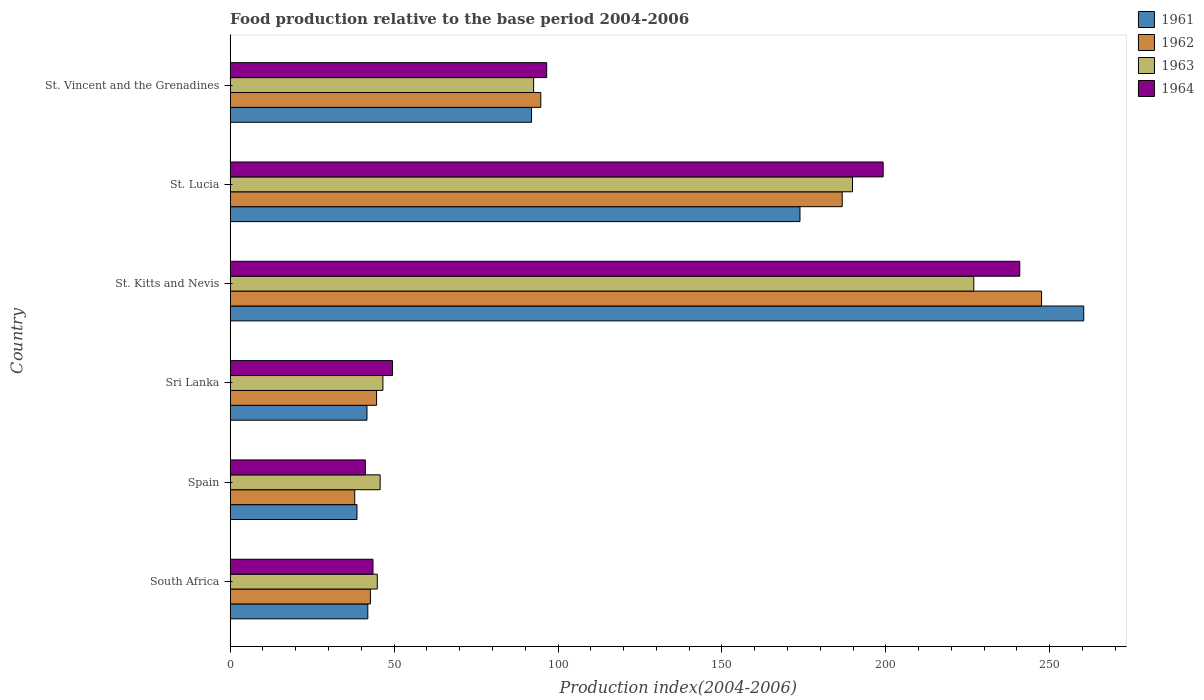How many groups of bars are there?
Keep it short and to the point. 6. Are the number of bars on each tick of the Y-axis equal?
Keep it short and to the point. Yes. How many bars are there on the 3rd tick from the top?
Your response must be concise. 4. How many bars are there on the 3rd tick from the bottom?
Provide a succinct answer. 4. What is the label of the 1st group of bars from the top?
Your answer should be compact. St. Vincent and the Grenadines. In how many cases, is the number of bars for a given country not equal to the number of legend labels?
Make the answer very short. 0. What is the food production index in 1961 in South Africa?
Make the answer very short. 41.98. Across all countries, what is the maximum food production index in 1962?
Ensure brevity in your answer.  247.5. Across all countries, what is the minimum food production index in 1962?
Make the answer very short. 37.99. In which country was the food production index in 1964 maximum?
Your answer should be very brief. St. Kitts and Nevis. In which country was the food production index in 1961 minimum?
Your answer should be very brief. Spain. What is the total food production index in 1963 in the graph?
Provide a short and direct response. 646.42. What is the difference between the food production index in 1963 in St. Kitts and Nevis and that in St. Vincent and the Grenadines?
Ensure brevity in your answer.  134.27. What is the difference between the food production index in 1964 in St. Vincent and the Grenadines and the food production index in 1961 in Sri Lanka?
Offer a terse response. 54.82. What is the average food production index in 1961 per country?
Ensure brevity in your answer.  108.08. What is the difference between the food production index in 1961 and food production index in 1963 in St. Lucia?
Provide a short and direct response. -16.02. In how many countries, is the food production index in 1962 greater than 100 ?
Provide a succinct answer. 2. What is the ratio of the food production index in 1962 in Spain to that in St. Lucia?
Your response must be concise. 0.2. Is the difference between the food production index in 1961 in South Africa and St. Lucia greater than the difference between the food production index in 1963 in South Africa and St. Lucia?
Keep it short and to the point. Yes. What is the difference between the highest and the second highest food production index in 1964?
Keep it short and to the point. 41.67. What is the difference between the highest and the lowest food production index in 1963?
Offer a very short reply. 181.96. In how many countries, is the food production index in 1962 greater than the average food production index in 1962 taken over all countries?
Offer a terse response. 2. What does the 4th bar from the bottom in St. Kitts and Nevis represents?
Your answer should be compact. 1964. Is it the case that in every country, the sum of the food production index in 1961 and food production index in 1964 is greater than the food production index in 1963?
Offer a very short reply. Yes. Does the graph contain grids?
Keep it short and to the point. No. How many legend labels are there?
Keep it short and to the point. 4. How are the legend labels stacked?
Your response must be concise. Vertical. What is the title of the graph?
Give a very brief answer. Food production relative to the base period 2004-2006. What is the label or title of the X-axis?
Offer a terse response. Production index(2004-2006). What is the Production index(2004-2006) of 1961 in South Africa?
Provide a short and direct response. 41.98. What is the Production index(2004-2006) in 1962 in South Africa?
Make the answer very short. 42.77. What is the Production index(2004-2006) in 1963 in South Africa?
Offer a very short reply. 44.87. What is the Production index(2004-2006) of 1964 in South Africa?
Provide a short and direct response. 43.56. What is the Production index(2004-2006) of 1961 in Spain?
Offer a very short reply. 38.68. What is the Production index(2004-2006) of 1962 in Spain?
Your response must be concise. 37.99. What is the Production index(2004-2006) in 1963 in Spain?
Make the answer very short. 45.74. What is the Production index(2004-2006) in 1964 in Spain?
Ensure brevity in your answer.  41.23. What is the Production index(2004-2006) in 1961 in Sri Lanka?
Your answer should be very brief. 41.73. What is the Production index(2004-2006) of 1962 in Sri Lanka?
Offer a very short reply. 44.66. What is the Production index(2004-2006) in 1963 in Sri Lanka?
Your answer should be compact. 46.59. What is the Production index(2004-2006) in 1964 in Sri Lanka?
Your response must be concise. 49.51. What is the Production index(2004-2006) in 1961 in St. Kitts and Nevis?
Keep it short and to the point. 260.37. What is the Production index(2004-2006) in 1962 in St. Kitts and Nevis?
Your response must be concise. 247.5. What is the Production index(2004-2006) in 1963 in St. Kitts and Nevis?
Ensure brevity in your answer.  226.83. What is the Production index(2004-2006) in 1964 in St. Kitts and Nevis?
Make the answer very short. 240.85. What is the Production index(2004-2006) of 1961 in St. Lucia?
Provide a succinct answer. 173.81. What is the Production index(2004-2006) in 1962 in St. Lucia?
Your answer should be very brief. 186.69. What is the Production index(2004-2006) of 1963 in St. Lucia?
Give a very brief answer. 189.83. What is the Production index(2004-2006) of 1964 in St. Lucia?
Your answer should be very brief. 199.18. What is the Production index(2004-2006) in 1961 in St. Vincent and the Grenadines?
Provide a short and direct response. 91.92. What is the Production index(2004-2006) in 1962 in St. Vincent and the Grenadines?
Give a very brief answer. 94.75. What is the Production index(2004-2006) in 1963 in St. Vincent and the Grenadines?
Offer a very short reply. 92.56. What is the Production index(2004-2006) of 1964 in St. Vincent and the Grenadines?
Your answer should be compact. 96.55. Across all countries, what is the maximum Production index(2004-2006) of 1961?
Your answer should be compact. 260.37. Across all countries, what is the maximum Production index(2004-2006) of 1962?
Make the answer very short. 247.5. Across all countries, what is the maximum Production index(2004-2006) of 1963?
Provide a short and direct response. 226.83. Across all countries, what is the maximum Production index(2004-2006) of 1964?
Offer a very short reply. 240.85. Across all countries, what is the minimum Production index(2004-2006) of 1961?
Make the answer very short. 38.68. Across all countries, what is the minimum Production index(2004-2006) of 1962?
Your answer should be compact. 37.99. Across all countries, what is the minimum Production index(2004-2006) in 1963?
Keep it short and to the point. 44.87. Across all countries, what is the minimum Production index(2004-2006) in 1964?
Offer a very short reply. 41.23. What is the total Production index(2004-2006) in 1961 in the graph?
Offer a very short reply. 648.49. What is the total Production index(2004-2006) of 1962 in the graph?
Offer a terse response. 654.36. What is the total Production index(2004-2006) in 1963 in the graph?
Offer a very short reply. 646.42. What is the total Production index(2004-2006) in 1964 in the graph?
Offer a terse response. 670.88. What is the difference between the Production index(2004-2006) of 1962 in South Africa and that in Spain?
Your answer should be very brief. 4.78. What is the difference between the Production index(2004-2006) of 1963 in South Africa and that in Spain?
Offer a very short reply. -0.87. What is the difference between the Production index(2004-2006) in 1964 in South Africa and that in Spain?
Provide a short and direct response. 2.33. What is the difference between the Production index(2004-2006) of 1962 in South Africa and that in Sri Lanka?
Your answer should be very brief. -1.89. What is the difference between the Production index(2004-2006) of 1963 in South Africa and that in Sri Lanka?
Your response must be concise. -1.72. What is the difference between the Production index(2004-2006) in 1964 in South Africa and that in Sri Lanka?
Your response must be concise. -5.95. What is the difference between the Production index(2004-2006) in 1961 in South Africa and that in St. Kitts and Nevis?
Your answer should be very brief. -218.39. What is the difference between the Production index(2004-2006) in 1962 in South Africa and that in St. Kitts and Nevis?
Provide a short and direct response. -204.73. What is the difference between the Production index(2004-2006) in 1963 in South Africa and that in St. Kitts and Nevis?
Ensure brevity in your answer.  -181.96. What is the difference between the Production index(2004-2006) in 1964 in South Africa and that in St. Kitts and Nevis?
Provide a short and direct response. -197.29. What is the difference between the Production index(2004-2006) in 1961 in South Africa and that in St. Lucia?
Your answer should be compact. -131.83. What is the difference between the Production index(2004-2006) of 1962 in South Africa and that in St. Lucia?
Your answer should be very brief. -143.92. What is the difference between the Production index(2004-2006) in 1963 in South Africa and that in St. Lucia?
Provide a short and direct response. -144.96. What is the difference between the Production index(2004-2006) of 1964 in South Africa and that in St. Lucia?
Your response must be concise. -155.62. What is the difference between the Production index(2004-2006) in 1961 in South Africa and that in St. Vincent and the Grenadines?
Offer a very short reply. -49.94. What is the difference between the Production index(2004-2006) of 1962 in South Africa and that in St. Vincent and the Grenadines?
Offer a very short reply. -51.98. What is the difference between the Production index(2004-2006) in 1963 in South Africa and that in St. Vincent and the Grenadines?
Your response must be concise. -47.69. What is the difference between the Production index(2004-2006) of 1964 in South Africa and that in St. Vincent and the Grenadines?
Give a very brief answer. -52.99. What is the difference between the Production index(2004-2006) in 1961 in Spain and that in Sri Lanka?
Offer a very short reply. -3.05. What is the difference between the Production index(2004-2006) in 1962 in Spain and that in Sri Lanka?
Make the answer very short. -6.67. What is the difference between the Production index(2004-2006) in 1963 in Spain and that in Sri Lanka?
Provide a short and direct response. -0.85. What is the difference between the Production index(2004-2006) in 1964 in Spain and that in Sri Lanka?
Give a very brief answer. -8.28. What is the difference between the Production index(2004-2006) of 1961 in Spain and that in St. Kitts and Nevis?
Make the answer very short. -221.69. What is the difference between the Production index(2004-2006) in 1962 in Spain and that in St. Kitts and Nevis?
Make the answer very short. -209.51. What is the difference between the Production index(2004-2006) of 1963 in Spain and that in St. Kitts and Nevis?
Give a very brief answer. -181.09. What is the difference between the Production index(2004-2006) in 1964 in Spain and that in St. Kitts and Nevis?
Offer a terse response. -199.62. What is the difference between the Production index(2004-2006) in 1961 in Spain and that in St. Lucia?
Offer a terse response. -135.13. What is the difference between the Production index(2004-2006) in 1962 in Spain and that in St. Lucia?
Offer a very short reply. -148.7. What is the difference between the Production index(2004-2006) of 1963 in Spain and that in St. Lucia?
Offer a terse response. -144.09. What is the difference between the Production index(2004-2006) in 1964 in Spain and that in St. Lucia?
Make the answer very short. -157.95. What is the difference between the Production index(2004-2006) of 1961 in Spain and that in St. Vincent and the Grenadines?
Your answer should be compact. -53.24. What is the difference between the Production index(2004-2006) in 1962 in Spain and that in St. Vincent and the Grenadines?
Provide a succinct answer. -56.76. What is the difference between the Production index(2004-2006) of 1963 in Spain and that in St. Vincent and the Grenadines?
Ensure brevity in your answer.  -46.82. What is the difference between the Production index(2004-2006) in 1964 in Spain and that in St. Vincent and the Grenadines?
Ensure brevity in your answer.  -55.32. What is the difference between the Production index(2004-2006) of 1961 in Sri Lanka and that in St. Kitts and Nevis?
Ensure brevity in your answer.  -218.64. What is the difference between the Production index(2004-2006) of 1962 in Sri Lanka and that in St. Kitts and Nevis?
Make the answer very short. -202.84. What is the difference between the Production index(2004-2006) in 1963 in Sri Lanka and that in St. Kitts and Nevis?
Offer a terse response. -180.24. What is the difference between the Production index(2004-2006) in 1964 in Sri Lanka and that in St. Kitts and Nevis?
Give a very brief answer. -191.34. What is the difference between the Production index(2004-2006) in 1961 in Sri Lanka and that in St. Lucia?
Provide a short and direct response. -132.08. What is the difference between the Production index(2004-2006) of 1962 in Sri Lanka and that in St. Lucia?
Keep it short and to the point. -142.03. What is the difference between the Production index(2004-2006) of 1963 in Sri Lanka and that in St. Lucia?
Make the answer very short. -143.24. What is the difference between the Production index(2004-2006) of 1964 in Sri Lanka and that in St. Lucia?
Offer a terse response. -149.67. What is the difference between the Production index(2004-2006) of 1961 in Sri Lanka and that in St. Vincent and the Grenadines?
Give a very brief answer. -50.19. What is the difference between the Production index(2004-2006) in 1962 in Sri Lanka and that in St. Vincent and the Grenadines?
Offer a very short reply. -50.09. What is the difference between the Production index(2004-2006) of 1963 in Sri Lanka and that in St. Vincent and the Grenadines?
Your answer should be compact. -45.97. What is the difference between the Production index(2004-2006) in 1964 in Sri Lanka and that in St. Vincent and the Grenadines?
Make the answer very short. -47.04. What is the difference between the Production index(2004-2006) of 1961 in St. Kitts and Nevis and that in St. Lucia?
Your answer should be very brief. 86.56. What is the difference between the Production index(2004-2006) of 1962 in St. Kitts and Nevis and that in St. Lucia?
Give a very brief answer. 60.81. What is the difference between the Production index(2004-2006) of 1963 in St. Kitts and Nevis and that in St. Lucia?
Your answer should be very brief. 37. What is the difference between the Production index(2004-2006) of 1964 in St. Kitts and Nevis and that in St. Lucia?
Provide a short and direct response. 41.67. What is the difference between the Production index(2004-2006) of 1961 in St. Kitts and Nevis and that in St. Vincent and the Grenadines?
Make the answer very short. 168.45. What is the difference between the Production index(2004-2006) in 1962 in St. Kitts and Nevis and that in St. Vincent and the Grenadines?
Your answer should be very brief. 152.75. What is the difference between the Production index(2004-2006) of 1963 in St. Kitts and Nevis and that in St. Vincent and the Grenadines?
Make the answer very short. 134.27. What is the difference between the Production index(2004-2006) in 1964 in St. Kitts and Nevis and that in St. Vincent and the Grenadines?
Make the answer very short. 144.3. What is the difference between the Production index(2004-2006) in 1961 in St. Lucia and that in St. Vincent and the Grenadines?
Your answer should be compact. 81.89. What is the difference between the Production index(2004-2006) of 1962 in St. Lucia and that in St. Vincent and the Grenadines?
Give a very brief answer. 91.94. What is the difference between the Production index(2004-2006) of 1963 in St. Lucia and that in St. Vincent and the Grenadines?
Your answer should be compact. 97.27. What is the difference between the Production index(2004-2006) of 1964 in St. Lucia and that in St. Vincent and the Grenadines?
Your answer should be compact. 102.63. What is the difference between the Production index(2004-2006) of 1961 in South Africa and the Production index(2004-2006) of 1962 in Spain?
Offer a terse response. 3.99. What is the difference between the Production index(2004-2006) in 1961 in South Africa and the Production index(2004-2006) in 1963 in Spain?
Provide a succinct answer. -3.76. What is the difference between the Production index(2004-2006) of 1962 in South Africa and the Production index(2004-2006) of 1963 in Spain?
Your answer should be compact. -2.97. What is the difference between the Production index(2004-2006) in 1962 in South Africa and the Production index(2004-2006) in 1964 in Spain?
Ensure brevity in your answer.  1.54. What is the difference between the Production index(2004-2006) of 1963 in South Africa and the Production index(2004-2006) of 1964 in Spain?
Your response must be concise. 3.64. What is the difference between the Production index(2004-2006) in 1961 in South Africa and the Production index(2004-2006) in 1962 in Sri Lanka?
Offer a terse response. -2.68. What is the difference between the Production index(2004-2006) in 1961 in South Africa and the Production index(2004-2006) in 1963 in Sri Lanka?
Offer a very short reply. -4.61. What is the difference between the Production index(2004-2006) of 1961 in South Africa and the Production index(2004-2006) of 1964 in Sri Lanka?
Offer a terse response. -7.53. What is the difference between the Production index(2004-2006) of 1962 in South Africa and the Production index(2004-2006) of 1963 in Sri Lanka?
Your response must be concise. -3.82. What is the difference between the Production index(2004-2006) of 1962 in South Africa and the Production index(2004-2006) of 1964 in Sri Lanka?
Make the answer very short. -6.74. What is the difference between the Production index(2004-2006) in 1963 in South Africa and the Production index(2004-2006) in 1964 in Sri Lanka?
Make the answer very short. -4.64. What is the difference between the Production index(2004-2006) of 1961 in South Africa and the Production index(2004-2006) of 1962 in St. Kitts and Nevis?
Give a very brief answer. -205.52. What is the difference between the Production index(2004-2006) of 1961 in South Africa and the Production index(2004-2006) of 1963 in St. Kitts and Nevis?
Make the answer very short. -184.85. What is the difference between the Production index(2004-2006) in 1961 in South Africa and the Production index(2004-2006) in 1964 in St. Kitts and Nevis?
Provide a succinct answer. -198.87. What is the difference between the Production index(2004-2006) of 1962 in South Africa and the Production index(2004-2006) of 1963 in St. Kitts and Nevis?
Make the answer very short. -184.06. What is the difference between the Production index(2004-2006) in 1962 in South Africa and the Production index(2004-2006) in 1964 in St. Kitts and Nevis?
Offer a very short reply. -198.08. What is the difference between the Production index(2004-2006) in 1963 in South Africa and the Production index(2004-2006) in 1964 in St. Kitts and Nevis?
Your answer should be compact. -195.98. What is the difference between the Production index(2004-2006) of 1961 in South Africa and the Production index(2004-2006) of 1962 in St. Lucia?
Make the answer very short. -144.71. What is the difference between the Production index(2004-2006) of 1961 in South Africa and the Production index(2004-2006) of 1963 in St. Lucia?
Offer a very short reply. -147.85. What is the difference between the Production index(2004-2006) of 1961 in South Africa and the Production index(2004-2006) of 1964 in St. Lucia?
Keep it short and to the point. -157.2. What is the difference between the Production index(2004-2006) of 1962 in South Africa and the Production index(2004-2006) of 1963 in St. Lucia?
Ensure brevity in your answer.  -147.06. What is the difference between the Production index(2004-2006) in 1962 in South Africa and the Production index(2004-2006) in 1964 in St. Lucia?
Keep it short and to the point. -156.41. What is the difference between the Production index(2004-2006) in 1963 in South Africa and the Production index(2004-2006) in 1964 in St. Lucia?
Keep it short and to the point. -154.31. What is the difference between the Production index(2004-2006) of 1961 in South Africa and the Production index(2004-2006) of 1962 in St. Vincent and the Grenadines?
Your response must be concise. -52.77. What is the difference between the Production index(2004-2006) in 1961 in South Africa and the Production index(2004-2006) in 1963 in St. Vincent and the Grenadines?
Your answer should be compact. -50.58. What is the difference between the Production index(2004-2006) in 1961 in South Africa and the Production index(2004-2006) in 1964 in St. Vincent and the Grenadines?
Give a very brief answer. -54.57. What is the difference between the Production index(2004-2006) in 1962 in South Africa and the Production index(2004-2006) in 1963 in St. Vincent and the Grenadines?
Ensure brevity in your answer.  -49.79. What is the difference between the Production index(2004-2006) in 1962 in South Africa and the Production index(2004-2006) in 1964 in St. Vincent and the Grenadines?
Offer a terse response. -53.78. What is the difference between the Production index(2004-2006) in 1963 in South Africa and the Production index(2004-2006) in 1964 in St. Vincent and the Grenadines?
Provide a succinct answer. -51.68. What is the difference between the Production index(2004-2006) of 1961 in Spain and the Production index(2004-2006) of 1962 in Sri Lanka?
Offer a very short reply. -5.98. What is the difference between the Production index(2004-2006) in 1961 in Spain and the Production index(2004-2006) in 1963 in Sri Lanka?
Offer a terse response. -7.91. What is the difference between the Production index(2004-2006) in 1961 in Spain and the Production index(2004-2006) in 1964 in Sri Lanka?
Ensure brevity in your answer.  -10.83. What is the difference between the Production index(2004-2006) of 1962 in Spain and the Production index(2004-2006) of 1963 in Sri Lanka?
Offer a very short reply. -8.6. What is the difference between the Production index(2004-2006) in 1962 in Spain and the Production index(2004-2006) in 1964 in Sri Lanka?
Offer a very short reply. -11.52. What is the difference between the Production index(2004-2006) of 1963 in Spain and the Production index(2004-2006) of 1964 in Sri Lanka?
Provide a short and direct response. -3.77. What is the difference between the Production index(2004-2006) in 1961 in Spain and the Production index(2004-2006) in 1962 in St. Kitts and Nevis?
Give a very brief answer. -208.82. What is the difference between the Production index(2004-2006) of 1961 in Spain and the Production index(2004-2006) of 1963 in St. Kitts and Nevis?
Ensure brevity in your answer.  -188.15. What is the difference between the Production index(2004-2006) in 1961 in Spain and the Production index(2004-2006) in 1964 in St. Kitts and Nevis?
Offer a terse response. -202.17. What is the difference between the Production index(2004-2006) of 1962 in Spain and the Production index(2004-2006) of 1963 in St. Kitts and Nevis?
Your answer should be very brief. -188.84. What is the difference between the Production index(2004-2006) of 1962 in Spain and the Production index(2004-2006) of 1964 in St. Kitts and Nevis?
Your answer should be very brief. -202.86. What is the difference between the Production index(2004-2006) of 1963 in Spain and the Production index(2004-2006) of 1964 in St. Kitts and Nevis?
Provide a succinct answer. -195.11. What is the difference between the Production index(2004-2006) in 1961 in Spain and the Production index(2004-2006) in 1962 in St. Lucia?
Make the answer very short. -148.01. What is the difference between the Production index(2004-2006) in 1961 in Spain and the Production index(2004-2006) in 1963 in St. Lucia?
Make the answer very short. -151.15. What is the difference between the Production index(2004-2006) in 1961 in Spain and the Production index(2004-2006) in 1964 in St. Lucia?
Give a very brief answer. -160.5. What is the difference between the Production index(2004-2006) in 1962 in Spain and the Production index(2004-2006) in 1963 in St. Lucia?
Offer a terse response. -151.84. What is the difference between the Production index(2004-2006) in 1962 in Spain and the Production index(2004-2006) in 1964 in St. Lucia?
Offer a terse response. -161.19. What is the difference between the Production index(2004-2006) in 1963 in Spain and the Production index(2004-2006) in 1964 in St. Lucia?
Your response must be concise. -153.44. What is the difference between the Production index(2004-2006) in 1961 in Spain and the Production index(2004-2006) in 1962 in St. Vincent and the Grenadines?
Keep it short and to the point. -56.07. What is the difference between the Production index(2004-2006) in 1961 in Spain and the Production index(2004-2006) in 1963 in St. Vincent and the Grenadines?
Your response must be concise. -53.88. What is the difference between the Production index(2004-2006) in 1961 in Spain and the Production index(2004-2006) in 1964 in St. Vincent and the Grenadines?
Make the answer very short. -57.87. What is the difference between the Production index(2004-2006) in 1962 in Spain and the Production index(2004-2006) in 1963 in St. Vincent and the Grenadines?
Provide a short and direct response. -54.57. What is the difference between the Production index(2004-2006) in 1962 in Spain and the Production index(2004-2006) in 1964 in St. Vincent and the Grenadines?
Make the answer very short. -58.56. What is the difference between the Production index(2004-2006) in 1963 in Spain and the Production index(2004-2006) in 1964 in St. Vincent and the Grenadines?
Ensure brevity in your answer.  -50.81. What is the difference between the Production index(2004-2006) of 1961 in Sri Lanka and the Production index(2004-2006) of 1962 in St. Kitts and Nevis?
Your response must be concise. -205.77. What is the difference between the Production index(2004-2006) in 1961 in Sri Lanka and the Production index(2004-2006) in 1963 in St. Kitts and Nevis?
Ensure brevity in your answer.  -185.1. What is the difference between the Production index(2004-2006) in 1961 in Sri Lanka and the Production index(2004-2006) in 1964 in St. Kitts and Nevis?
Your answer should be compact. -199.12. What is the difference between the Production index(2004-2006) of 1962 in Sri Lanka and the Production index(2004-2006) of 1963 in St. Kitts and Nevis?
Give a very brief answer. -182.17. What is the difference between the Production index(2004-2006) in 1962 in Sri Lanka and the Production index(2004-2006) in 1964 in St. Kitts and Nevis?
Offer a very short reply. -196.19. What is the difference between the Production index(2004-2006) of 1963 in Sri Lanka and the Production index(2004-2006) of 1964 in St. Kitts and Nevis?
Provide a succinct answer. -194.26. What is the difference between the Production index(2004-2006) in 1961 in Sri Lanka and the Production index(2004-2006) in 1962 in St. Lucia?
Give a very brief answer. -144.96. What is the difference between the Production index(2004-2006) in 1961 in Sri Lanka and the Production index(2004-2006) in 1963 in St. Lucia?
Your answer should be very brief. -148.1. What is the difference between the Production index(2004-2006) of 1961 in Sri Lanka and the Production index(2004-2006) of 1964 in St. Lucia?
Ensure brevity in your answer.  -157.45. What is the difference between the Production index(2004-2006) in 1962 in Sri Lanka and the Production index(2004-2006) in 1963 in St. Lucia?
Offer a very short reply. -145.17. What is the difference between the Production index(2004-2006) of 1962 in Sri Lanka and the Production index(2004-2006) of 1964 in St. Lucia?
Ensure brevity in your answer.  -154.52. What is the difference between the Production index(2004-2006) in 1963 in Sri Lanka and the Production index(2004-2006) in 1964 in St. Lucia?
Offer a very short reply. -152.59. What is the difference between the Production index(2004-2006) in 1961 in Sri Lanka and the Production index(2004-2006) in 1962 in St. Vincent and the Grenadines?
Give a very brief answer. -53.02. What is the difference between the Production index(2004-2006) in 1961 in Sri Lanka and the Production index(2004-2006) in 1963 in St. Vincent and the Grenadines?
Provide a short and direct response. -50.83. What is the difference between the Production index(2004-2006) in 1961 in Sri Lanka and the Production index(2004-2006) in 1964 in St. Vincent and the Grenadines?
Your answer should be very brief. -54.82. What is the difference between the Production index(2004-2006) of 1962 in Sri Lanka and the Production index(2004-2006) of 1963 in St. Vincent and the Grenadines?
Provide a succinct answer. -47.9. What is the difference between the Production index(2004-2006) of 1962 in Sri Lanka and the Production index(2004-2006) of 1964 in St. Vincent and the Grenadines?
Give a very brief answer. -51.89. What is the difference between the Production index(2004-2006) in 1963 in Sri Lanka and the Production index(2004-2006) in 1964 in St. Vincent and the Grenadines?
Make the answer very short. -49.96. What is the difference between the Production index(2004-2006) of 1961 in St. Kitts and Nevis and the Production index(2004-2006) of 1962 in St. Lucia?
Offer a very short reply. 73.68. What is the difference between the Production index(2004-2006) of 1961 in St. Kitts and Nevis and the Production index(2004-2006) of 1963 in St. Lucia?
Ensure brevity in your answer.  70.54. What is the difference between the Production index(2004-2006) in 1961 in St. Kitts and Nevis and the Production index(2004-2006) in 1964 in St. Lucia?
Give a very brief answer. 61.19. What is the difference between the Production index(2004-2006) in 1962 in St. Kitts and Nevis and the Production index(2004-2006) in 1963 in St. Lucia?
Ensure brevity in your answer.  57.67. What is the difference between the Production index(2004-2006) in 1962 in St. Kitts and Nevis and the Production index(2004-2006) in 1964 in St. Lucia?
Provide a short and direct response. 48.32. What is the difference between the Production index(2004-2006) in 1963 in St. Kitts and Nevis and the Production index(2004-2006) in 1964 in St. Lucia?
Your response must be concise. 27.65. What is the difference between the Production index(2004-2006) of 1961 in St. Kitts and Nevis and the Production index(2004-2006) of 1962 in St. Vincent and the Grenadines?
Your answer should be compact. 165.62. What is the difference between the Production index(2004-2006) of 1961 in St. Kitts and Nevis and the Production index(2004-2006) of 1963 in St. Vincent and the Grenadines?
Provide a succinct answer. 167.81. What is the difference between the Production index(2004-2006) in 1961 in St. Kitts and Nevis and the Production index(2004-2006) in 1964 in St. Vincent and the Grenadines?
Make the answer very short. 163.82. What is the difference between the Production index(2004-2006) of 1962 in St. Kitts and Nevis and the Production index(2004-2006) of 1963 in St. Vincent and the Grenadines?
Offer a very short reply. 154.94. What is the difference between the Production index(2004-2006) in 1962 in St. Kitts and Nevis and the Production index(2004-2006) in 1964 in St. Vincent and the Grenadines?
Keep it short and to the point. 150.95. What is the difference between the Production index(2004-2006) in 1963 in St. Kitts and Nevis and the Production index(2004-2006) in 1964 in St. Vincent and the Grenadines?
Your answer should be very brief. 130.28. What is the difference between the Production index(2004-2006) in 1961 in St. Lucia and the Production index(2004-2006) in 1962 in St. Vincent and the Grenadines?
Your answer should be compact. 79.06. What is the difference between the Production index(2004-2006) of 1961 in St. Lucia and the Production index(2004-2006) of 1963 in St. Vincent and the Grenadines?
Your answer should be very brief. 81.25. What is the difference between the Production index(2004-2006) of 1961 in St. Lucia and the Production index(2004-2006) of 1964 in St. Vincent and the Grenadines?
Provide a succinct answer. 77.26. What is the difference between the Production index(2004-2006) of 1962 in St. Lucia and the Production index(2004-2006) of 1963 in St. Vincent and the Grenadines?
Make the answer very short. 94.13. What is the difference between the Production index(2004-2006) in 1962 in St. Lucia and the Production index(2004-2006) in 1964 in St. Vincent and the Grenadines?
Provide a succinct answer. 90.14. What is the difference between the Production index(2004-2006) in 1963 in St. Lucia and the Production index(2004-2006) in 1964 in St. Vincent and the Grenadines?
Ensure brevity in your answer.  93.28. What is the average Production index(2004-2006) of 1961 per country?
Offer a terse response. 108.08. What is the average Production index(2004-2006) in 1962 per country?
Provide a succinct answer. 109.06. What is the average Production index(2004-2006) of 1963 per country?
Provide a succinct answer. 107.74. What is the average Production index(2004-2006) in 1964 per country?
Ensure brevity in your answer.  111.81. What is the difference between the Production index(2004-2006) in 1961 and Production index(2004-2006) in 1962 in South Africa?
Offer a terse response. -0.79. What is the difference between the Production index(2004-2006) in 1961 and Production index(2004-2006) in 1963 in South Africa?
Your answer should be very brief. -2.89. What is the difference between the Production index(2004-2006) of 1961 and Production index(2004-2006) of 1964 in South Africa?
Give a very brief answer. -1.58. What is the difference between the Production index(2004-2006) of 1962 and Production index(2004-2006) of 1963 in South Africa?
Provide a succinct answer. -2.1. What is the difference between the Production index(2004-2006) in 1962 and Production index(2004-2006) in 1964 in South Africa?
Provide a succinct answer. -0.79. What is the difference between the Production index(2004-2006) in 1963 and Production index(2004-2006) in 1964 in South Africa?
Make the answer very short. 1.31. What is the difference between the Production index(2004-2006) of 1961 and Production index(2004-2006) of 1962 in Spain?
Make the answer very short. 0.69. What is the difference between the Production index(2004-2006) of 1961 and Production index(2004-2006) of 1963 in Spain?
Your answer should be compact. -7.06. What is the difference between the Production index(2004-2006) of 1961 and Production index(2004-2006) of 1964 in Spain?
Ensure brevity in your answer.  -2.55. What is the difference between the Production index(2004-2006) in 1962 and Production index(2004-2006) in 1963 in Spain?
Give a very brief answer. -7.75. What is the difference between the Production index(2004-2006) of 1962 and Production index(2004-2006) of 1964 in Spain?
Provide a succinct answer. -3.24. What is the difference between the Production index(2004-2006) of 1963 and Production index(2004-2006) of 1964 in Spain?
Keep it short and to the point. 4.51. What is the difference between the Production index(2004-2006) in 1961 and Production index(2004-2006) in 1962 in Sri Lanka?
Your answer should be compact. -2.93. What is the difference between the Production index(2004-2006) in 1961 and Production index(2004-2006) in 1963 in Sri Lanka?
Your answer should be compact. -4.86. What is the difference between the Production index(2004-2006) in 1961 and Production index(2004-2006) in 1964 in Sri Lanka?
Give a very brief answer. -7.78. What is the difference between the Production index(2004-2006) of 1962 and Production index(2004-2006) of 1963 in Sri Lanka?
Offer a terse response. -1.93. What is the difference between the Production index(2004-2006) of 1962 and Production index(2004-2006) of 1964 in Sri Lanka?
Keep it short and to the point. -4.85. What is the difference between the Production index(2004-2006) in 1963 and Production index(2004-2006) in 1964 in Sri Lanka?
Offer a terse response. -2.92. What is the difference between the Production index(2004-2006) of 1961 and Production index(2004-2006) of 1962 in St. Kitts and Nevis?
Provide a succinct answer. 12.87. What is the difference between the Production index(2004-2006) in 1961 and Production index(2004-2006) in 1963 in St. Kitts and Nevis?
Give a very brief answer. 33.54. What is the difference between the Production index(2004-2006) of 1961 and Production index(2004-2006) of 1964 in St. Kitts and Nevis?
Your answer should be very brief. 19.52. What is the difference between the Production index(2004-2006) in 1962 and Production index(2004-2006) in 1963 in St. Kitts and Nevis?
Your answer should be very brief. 20.67. What is the difference between the Production index(2004-2006) in 1962 and Production index(2004-2006) in 1964 in St. Kitts and Nevis?
Give a very brief answer. 6.65. What is the difference between the Production index(2004-2006) in 1963 and Production index(2004-2006) in 1964 in St. Kitts and Nevis?
Ensure brevity in your answer.  -14.02. What is the difference between the Production index(2004-2006) in 1961 and Production index(2004-2006) in 1962 in St. Lucia?
Offer a terse response. -12.88. What is the difference between the Production index(2004-2006) in 1961 and Production index(2004-2006) in 1963 in St. Lucia?
Your response must be concise. -16.02. What is the difference between the Production index(2004-2006) in 1961 and Production index(2004-2006) in 1964 in St. Lucia?
Provide a short and direct response. -25.37. What is the difference between the Production index(2004-2006) of 1962 and Production index(2004-2006) of 1963 in St. Lucia?
Make the answer very short. -3.14. What is the difference between the Production index(2004-2006) in 1962 and Production index(2004-2006) in 1964 in St. Lucia?
Provide a short and direct response. -12.49. What is the difference between the Production index(2004-2006) of 1963 and Production index(2004-2006) of 1964 in St. Lucia?
Give a very brief answer. -9.35. What is the difference between the Production index(2004-2006) in 1961 and Production index(2004-2006) in 1962 in St. Vincent and the Grenadines?
Make the answer very short. -2.83. What is the difference between the Production index(2004-2006) of 1961 and Production index(2004-2006) of 1963 in St. Vincent and the Grenadines?
Keep it short and to the point. -0.64. What is the difference between the Production index(2004-2006) of 1961 and Production index(2004-2006) of 1964 in St. Vincent and the Grenadines?
Your answer should be very brief. -4.63. What is the difference between the Production index(2004-2006) in 1962 and Production index(2004-2006) in 1963 in St. Vincent and the Grenadines?
Make the answer very short. 2.19. What is the difference between the Production index(2004-2006) of 1963 and Production index(2004-2006) of 1964 in St. Vincent and the Grenadines?
Make the answer very short. -3.99. What is the ratio of the Production index(2004-2006) in 1961 in South Africa to that in Spain?
Keep it short and to the point. 1.09. What is the ratio of the Production index(2004-2006) in 1962 in South Africa to that in Spain?
Your answer should be very brief. 1.13. What is the ratio of the Production index(2004-2006) of 1964 in South Africa to that in Spain?
Offer a very short reply. 1.06. What is the ratio of the Production index(2004-2006) of 1961 in South Africa to that in Sri Lanka?
Make the answer very short. 1.01. What is the ratio of the Production index(2004-2006) of 1962 in South Africa to that in Sri Lanka?
Ensure brevity in your answer.  0.96. What is the ratio of the Production index(2004-2006) of 1963 in South Africa to that in Sri Lanka?
Your response must be concise. 0.96. What is the ratio of the Production index(2004-2006) of 1964 in South Africa to that in Sri Lanka?
Offer a terse response. 0.88. What is the ratio of the Production index(2004-2006) in 1961 in South Africa to that in St. Kitts and Nevis?
Keep it short and to the point. 0.16. What is the ratio of the Production index(2004-2006) of 1962 in South Africa to that in St. Kitts and Nevis?
Your answer should be compact. 0.17. What is the ratio of the Production index(2004-2006) of 1963 in South Africa to that in St. Kitts and Nevis?
Your answer should be very brief. 0.2. What is the ratio of the Production index(2004-2006) in 1964 in South Africa to that in St. Kitts and Nevis?
Ensure brevity in your answer.  0.18. What is the ratio of the Production index(2004-2006) of 1961 in South Africa to that in St. Lucia?
Ensure brevity in your answer.  0.24. What is the ratio of the Production index(2004-2006) in 1962 in South Africa to that in St. Lucia?
Make the answer very short. 0.23. What is the ratio of the Production index(2004-2006) in 1963 in South Africa to that in St. Lucia?
Provide a short and direct response. 0.24. What is the ratio of the Production index(2004-2006) of 1964 in South Africa to that in St. Lucia?
Make the answer very short. 0.22. What is the ratio of the Production index(2004-2006) in 1961 in South Africa to that in St. Vincent and the Grenadines?
Give a very brief answer. 0.46. What is the ratio of the Production index(2004-2006) of 1962 in South Africa to that in St. Vincent and the Grenadines?
Offer a very short reply. 0.45. What is the ratio of the Production index(2004-2006) of 1963 in South Africa to that in St. Vincent and the Grenadines?
Keep it short and to the point. 0.48. What is the ratio of the Production index(2004-2006) of 1964 in South Africa to that in St. Vincent and the Grenadines?
Offer a very short reply. 0.45. What is the ratio of the Production index(2004-2006) of 1961 in Spain to that in Sri Lanka?
Keep it short and to the point. 0.93. What is the ratio of the Production index(2004-2006) of 1962 in Spain to that in Sri Lanka?
Ensure brevity in your answer.  0.85. What is the ratio of the Production index(2004-2006) in 1963 in Spain to that in Sri Lanka?
Your answer should be compact. 0.98. What is the ratio of the Production index(2004-2006) of 1964 in Spain to that in Sri Lanka?
Ensure brevity in your answer.  0.83. What is the ratio of the Production index(2004-2006) of 1961 in Spain to that in St. Kitts and Nevis?
Your answer should be very brief. 0.15. What is the ratio of the Production index(2004-2006) of 1962 in Spain to that in St. Kitts and Nevis?
Provide a short and direct response. 0.15. What is the ratio of the Production index(2004-2006) of 1963 in Spain to that in St. Kitts and Nevis?
Provide a succinct answer. 0.2. What is the ratio of the Production index(2004-2006) of 1964 in Spain to that in St. Kitts and Nevis?
Keep it short and to the point. 0.17. What is the ratio of the Production index(2004-2006) of 1961 in Spain to that in St. Lucia?
Offer a very short reply. 0.22. What is the ratio of the Production index(2004-2006) in 1962 in Spain to that in St. Lucia?
Keep it short and to the point. 0.2. What is the ratio of the Production index(2004-2006) of 1963 in Spain to that in St. Lucia?
Give a very brief answer. 0.24. What is the ratio of the Production index(2004-2006) in 1964 in Spain to that in St. Lucia?
Offer a terse response. 0.21. What is the ratio of the Production index(2004-2006) in 1961 in Spain to that in St. Vincent and the Grenadines?
Ensure brevity in your answer.  0.42. What is the ratio of the Production index(2004-2006) in 1962 in Spain to that in St. Vincent and the Grenadines?
Offer a terse response. 0.4. What is the ratio of the Production index(2004-2006) in 1963 in Spain to that in St. Vincent and the Grenadines?
Offer a very short reply. 0.49. What is the ratio of the Production index(2004-2006) in 1964 in Spain to that in St. Vincent and the Grenadines?
Give a very brief answer. 0.43. What is the ratio of the Production index(2004-2006) of 1961 in Sri Lanka to that in St. Kitts and Nevis?
Your response must be concise. 0.16. What is the ratio of the Production index(2004-2006) in 1962 in Sri Lanka to that in St. Kitts and Nevis?
Keep it short and to the point. 0.18. What is the ratio of the Production index(2004-2006) in 1963 in Sri Lanka to that in St. Kitts and Nevis?
Ensure brevity in your answer.  0.21. What is the ratio of the Production index(2004-2006) in 1964 in Sri Lanka to that in St. Kitts and Nevis?
Your response must be concise. 0.21. What is the ratio of the Production index(2004-2006) in 1961 in Sri Lanka to that in St. Lucia?
Provide a succinct answer. 0.24. What is the ratio of the Production index(2004-2006) of 1962 in Sri Lanka to that in St. Lucia?
Ensure brevity in your answer.  0.24. What is the ratio of the Production index(2004-2006) of 1963 in Sri Lanka to that in St. Lucia?
Your response must be concise. 0.25. What is the ratio of the Production index(2004-2006) of 1964 in Sri Lanka to that in St. Lucia?
Offer a terse response. 0.25. What is the ratio of the Production index(2004-2006) of 1961 in Sri Lanka to that in St. Vincent and the Grenadines?
Your answer should be very brief. 0.45. What is the ratio of the Production index(2004-2006) of 1962 in Sri Lanka to that in St. Vincent and the Grenadines?
Offer a very short reply. 0.47. What is the ratio of the Production index(2004-2006) of 1963 in Sri Lanka to that in St. Vincent and the Grenadines?
Make the answer very short. 0.5. What is the ratio of the Production index(2004-2006) in 1964 in Sri Lanka to that in St. Vincent and the Grenadines?
Provide a short and direct response. 0.51. What is the ratio of the Production index(2004-2006) in 1961 in St. Kitts and Nevis to that in St. Lucia?
Provide a short and direct response. 1.5. What is the ratio of the Production index(2004-2006) in 1962 in St. Kitts and Nevis to that in St. Lucia?
Your answer should be compact. 1.33. What is the ratio of the Production index(2004-2006) of 1963 in St. Kitts and Nevis to that in St. Lucia?
Make the answer very short. 1.19. What is the ratio of the Production index(2004-2006) of 1964 in St. Kitts and Nevis to that in St. Lucia?
Give a very brief answer. 1.21. What is the ratio of the Production index(2004-2006) in 1961 in St. Kitts and Nevis to that in St. Vincent and the Grenadines?
Offer a terse response. 2.83. What is the ratio of the Production index(2004-2006) in 1962 in St. Kitts and Nevis to that in St. Vincent and the Grenadines?
Your answer should be very brief. 2.61. What is the ratio of the Production index(2004-2006) in 1963 in St. Kitts and Nevis to that in St. Vincent and the Grenadines?
Ensure brevity in your answer.  2.45. What is the ratio of the Production index(2004-2006) of 1964 in St. Kitts and Nevis to that in St. Vincent and the Grenadines?
Offer a terse response. 2.49. What is the ratio of the Production index(2004-2006) of 1961 in St. Lucia to that in St. Vincent and the Grenadines?
Provide a short and direct response. 1.89. What is the ratio of the Production index(2004-2006) in 1962 in St. Lucia to that in St. Vincent and the Grenadines?
Provide a succinct answer. 1.97. What is the ratio of the Production index(2004-2006) in 1963 in St. Lucia to that in St. Vincent and the Grenadines?
Make the answer very short. 2.05. What is the ratio of the Production index(2004-2006) in 1964 in St. Lucia to that in St. Vincent and the Grenadines?
Keep it short and to the point. 2.06. What is the difference between the highest and the second highest Production index(2004-2006) of 1961?
Give a very brief answer. 86.56. What is the difference between the highest and the second highest Production index(2004-2006) in 1962?
Ensure brevity in your answer.  60.81. What is the difference between the highest and the second highest Production index(2004-2006) in 1964?
Provide a succinct answer. 41.67. What is the difference between the highest and the lowest Production index(2004-2006) in 1961?
Provide a succinct answer. 221.69. What is the difference between the highest and the lowest Production index(2004-2006) of 1962?
Provide a succinct answer. 209.51. What is the difference between the highest and the lowest Production index(2004-2006) of 1963?
Keep it short and to the point. 181.96. What is the difference between the highest and the lowest Production index(2004-2006) in 1964?
Provide a succinct answer. 199.62. 